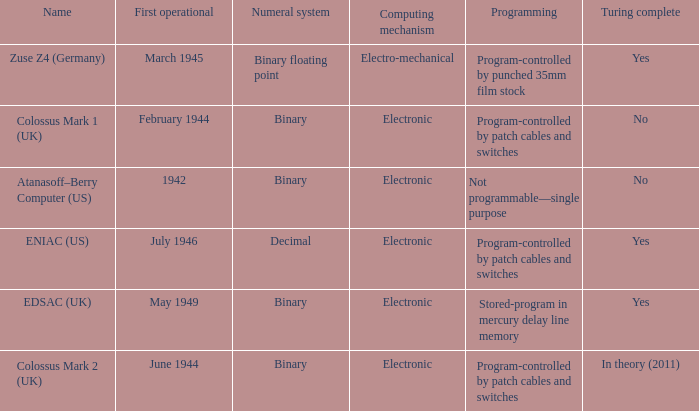What is the computing mechanism called atanasoff-berry computer (us)? Electronic. 